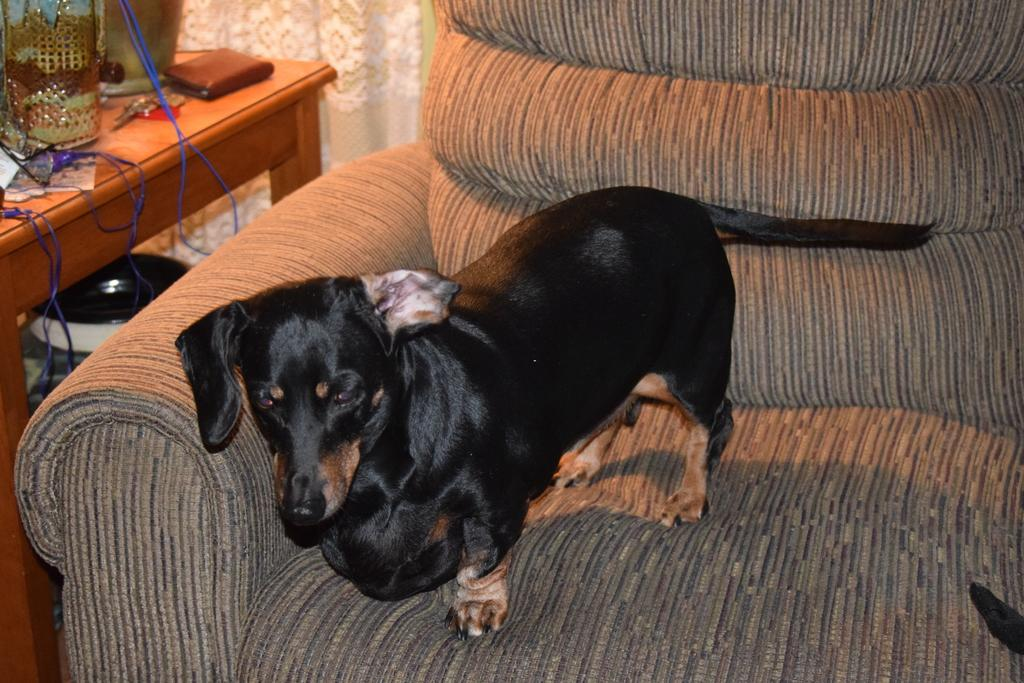What is the animal sitting on the couch in the image? There is a dog sitting on a couch in the image. What is located beside the couch? There is a table beside the couch in the image. What items can be seen on the table? There is a wallet, a container, and a cable on the table in the image. Can you see a tiger flying a plane on this particular day in the image? No, there is no tiger, plane, or reference to a specific day in the image. 